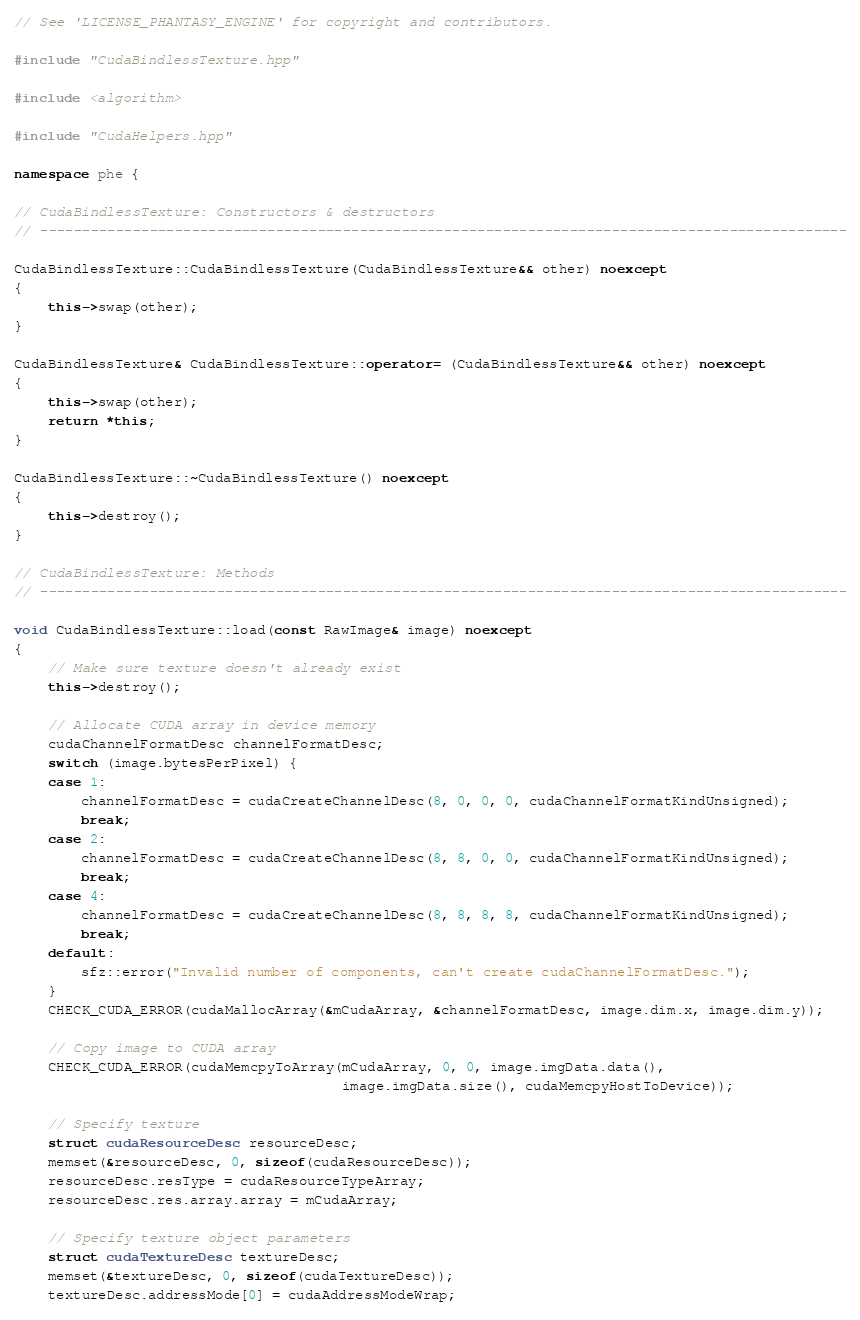Convert code to text. <code><loc_0><loc_0><loc_500><loc_500><_C++_>// See 'LICENSE_PHANTASY_ENGINE' for copyright and contributors.

#include "CudaBindlessTexture.hpp"

#include <algorithm>

#include "CudaHelpers.hpp"

namespace phe {

// CudaBindlessTexture: Constructors & destructors
// ------------------------------------------------------------------------------------------------

CudaBindlessTexture::CudaBindlessTexture(CudaBindlessTexture&& other) noexcept
{
	this->swap(other);
}

CudaBindlessTexture& CudaBindlessTexture::operator= (CudaBindlessTexture&& other) noexcept
{
	this->swap(other);
	return *this;
}

CudaBindlessTexture::~CudaBindlessTexture() noexcept
{
	this->destroy();
}

// CudaBindlessTexture: Methods
// ------------------------------------------------------------------------------------------------

void CudaBindlessTexture::load(const RawImage& image) noexcept
{
	// Make sure texture doesn't already exist
	this->destroy();

	// Allocate CUDA array in device memory
	cudaChannelFormatDesc channelFormatDesc;
	switch (image.bytesPerPixel) {
	case 1:
		channelFormatDesc = cudaCreateChannelDesc(8, 0, 0, 0, cudaChannelFormatKindUnsigned);
		break;
	case 2:
		channelFormatDesc = cudaCreateChannelDesc(8, 8, 0, 0, cudaChannelFormatKindUnsigned);
		break;
	case 4:
		channelFormatDesc = cudaCreateChannelDesc(8, 8, 8, 8, cudaChannelFormatKindUnsigned);
		break;
	default:
		sfz::error("Invalid number of components, can't create cudaChannelFormatDesc.");
	}
	CHECK_CUDA_ERROR(cudaMallocArray(&mCudaArray, &channelFormatDesc, image.dim.x, image.dim.y));

	// Copy image to CUDA array
	CHECK_CUDA_ERROR(cudaMemcpyToArray(mCudaArray, 0, 0, image.imgData.data(),
	                                   image.imgData.size(), cudaMemcpyHostToDevice));

	// Specify texture
	struct cudaResourceDesc resourceDesc;
	memset(&resourceDesc, 0, sizeof(cudaResourceDesc));
	resourceDesc.resType = cudaResourceTypeArray;
	resourceDesc.res.array.array = mCudaArray;

	// Specify texture object parameters
	struct cudaTextureDesc textureDesc;
	memset(&textureDesc, 0, sizeof(cudaTextureDesc));
	textureDesc.addressMode[0] = cudaAddressModeWrap;</code> 